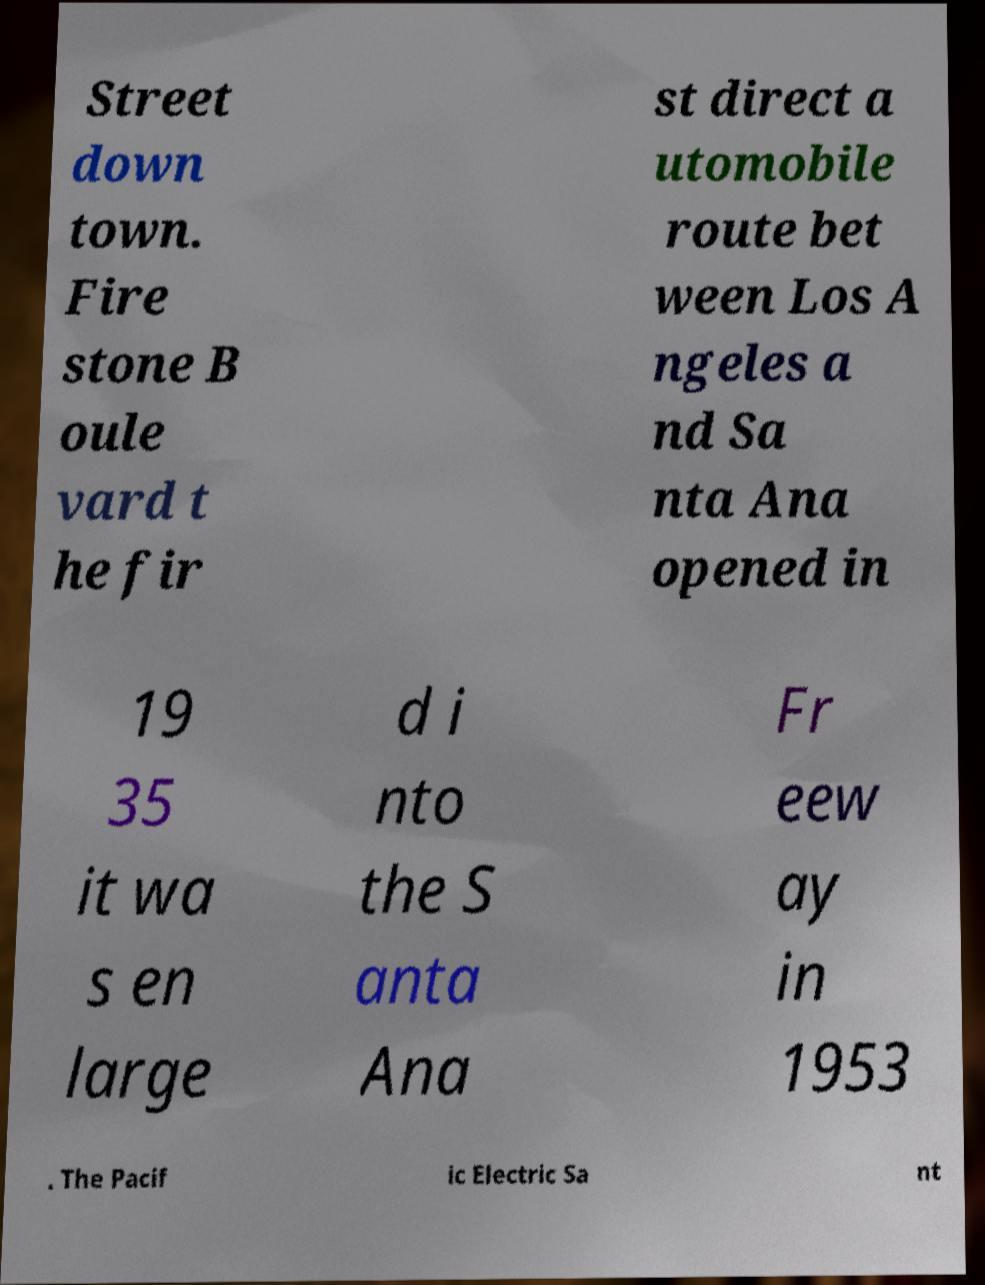Can you accurately transcribe the text from the provided image for me? Street down town. Fire stone B oule vard t he fir st direct a utomobile route bet ween Los A ngeles a nd Sa nta Ana opened in 19 35 it wa s en large d i nto the S anta Ana Fr eew ay in 1953 . The Pacif ic Electric Sa nt 